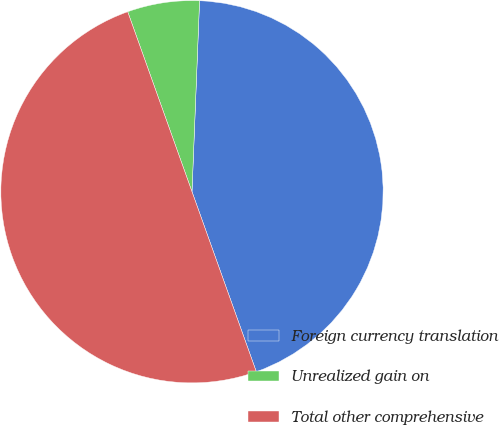<chart> <loc_0><loc_0><loc_500><loc_500><pie_chart><fcel>Foreign currency translation<fcel>Unrealized gain on<fcel>Total other comprehensive<nl><fcel>43.91%<fcel>6.09%<fcel>50.0%<nl></chart> 